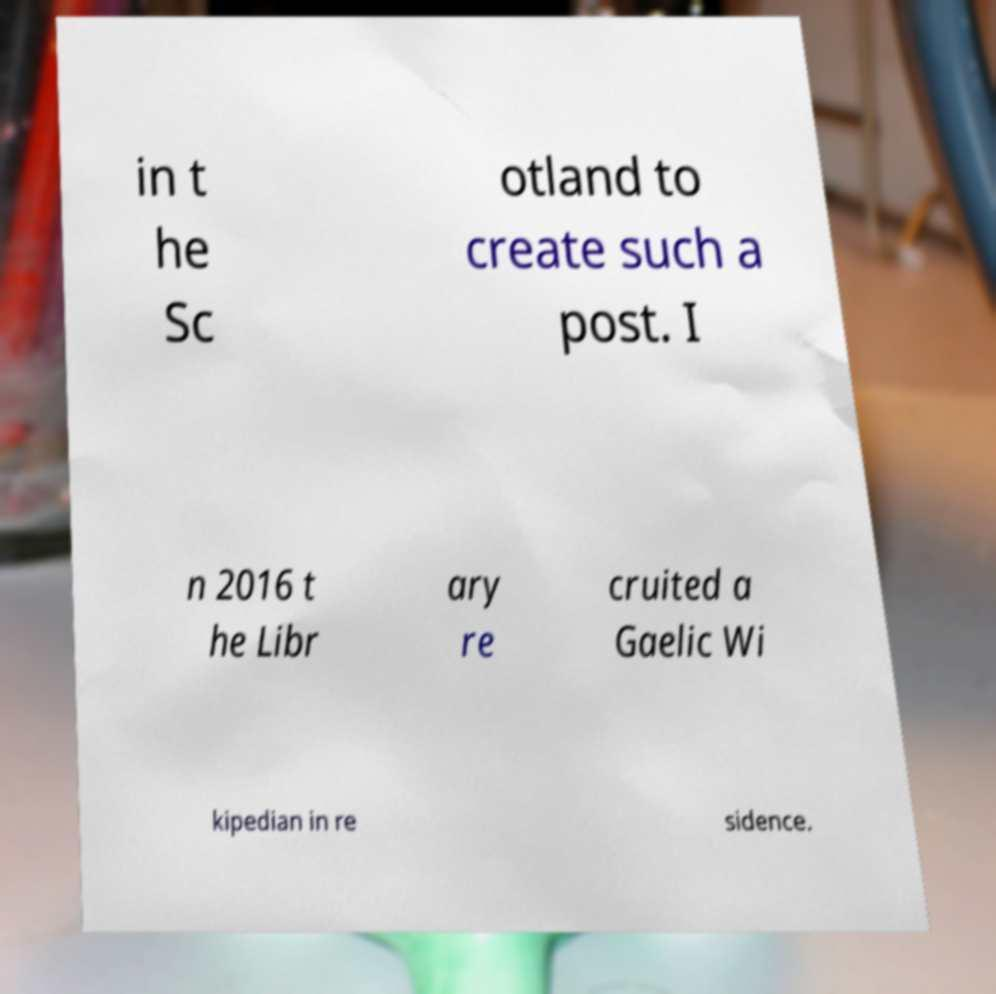Could you extract and type out the text from this image? in t he Sc otland to create such a post. I n 2016 t he Libr ary re cruited a Gaelic Wi kipedian in re sidence. 